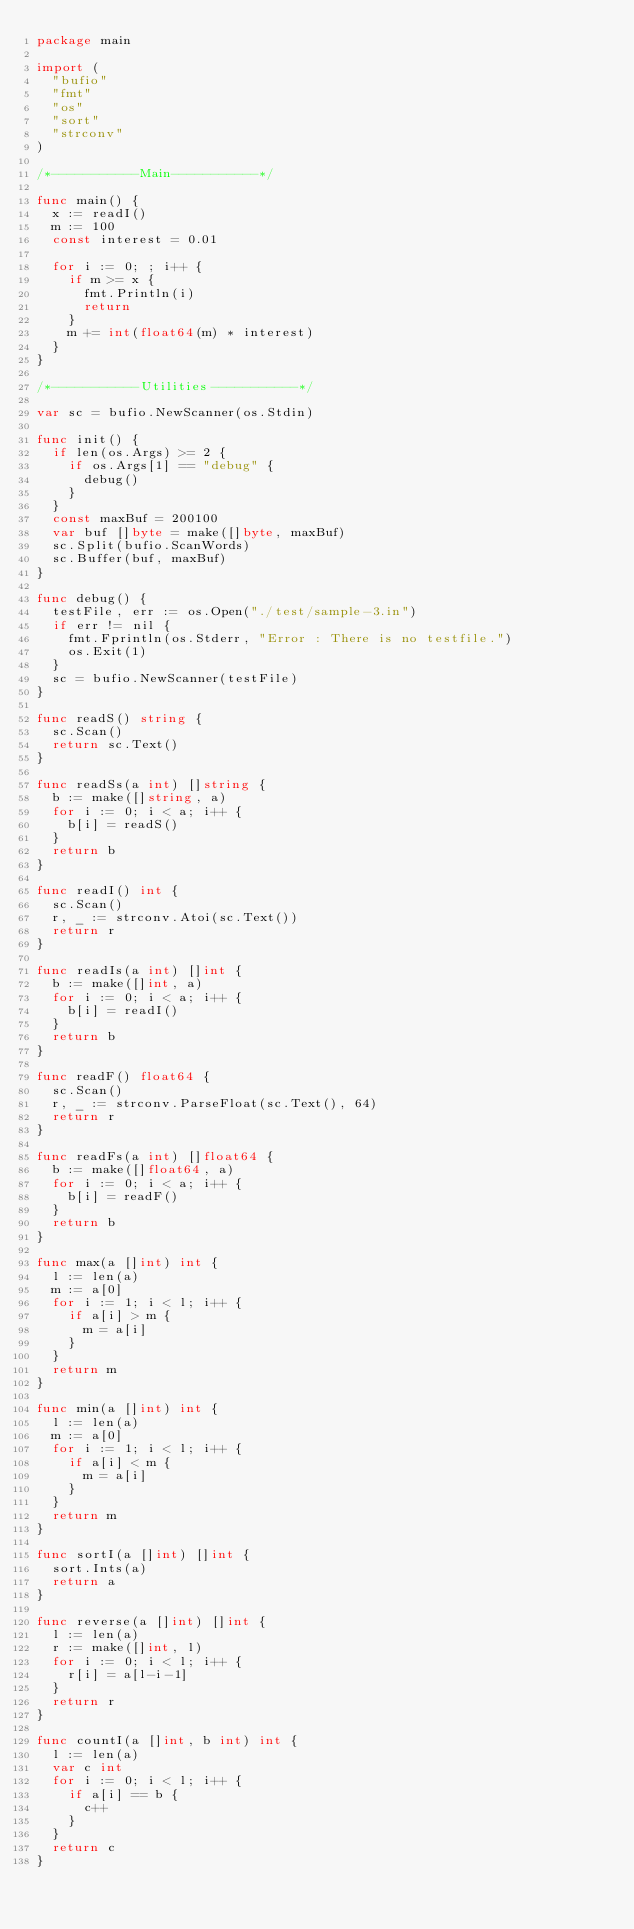Convert code to text. <code><loc_0><loc_0><loc_500><loc_500><_Go_>package main

import (
	"bufio"
	"fmt"
	"os"
	"sort"
	"strconv"
)

/*-----------Main-----------*/

func main() {
	x := readI()
	m := 100
	const interest = 0.01

	for i := 0; ; i++ {
		if m >= x {
			fmt.Println(i)
			return
		}
		m += int(float64(m) * interest)
	}
}

/*-----------Utilities-----------*/

var sc = bufio.NewScanner(os.Stdin)

func init() {
	if len(os.Args) >= 2 {
		if os.Args[1] == "debug" {
			debug()
		}
	}
	const maxBuf = 200100
	var buf []byte = make([]byte, maxBuf)
	sc.Split(bufio.ScanWords)
	sc.Buffer(buf, maxBuf)
}

func debug() {
	testFile, err := os.Open("./test/sample-3.in")
	if err != nil {
		fmt.Fprintln(os.Stderr, "Error : There is no testfile.")
		os.Exit(1)
	}
	sc = bufio.NewScanner(testFile)
}

func readS() string {
	sc.Scan()
	return sc.Text()
}

func readSs(a int) []string {
	b := make([]string, a)
	for i := 0; i < a; i++ {
		b[i] = readS()
	}
	return b
}

func readI() int {
	sc.Scan()
	r, _ := strconv.Atoi(sc.Text())
	return r
}

func readIs(a int) []int {
	b := make([]int, a)
	for i := 0; i < a; i++ {
		b[i] = readI()
	}
	return b
}

func readF() float64 {
	sc.Scan()
	r, _ := strconv.ParseFloat(sc.Text(), 64)
	return r
}

func readFs(a int) []float64 {
	b := make([]float64, a)
	for i := 0; i < a; i++ {
		b[i] = readF()
	}
	return b
}

func max(a []int) int {
	l := len(a)
	m := a[0]
	for i := 1; i < l; i++ {
		if a[i] > m {
			m = a[i]
		}
	}
	return m
}

func min(a []int) int {
	l := len(a)
	m := a[0]
	for i := 1; i < l; i++ {
		if a[i] < m {
			m = a[i]
		}
	}
	return m
}

func sortI(a []int) []int {
	sort.Ints(a)
	return a
}

func reverse(a []int) []int {
	l := len(a)
	r := make([]int, l)
	for i := 0; i < l; i++ {
		r[i] = a[l-i-1]
	}
	return r
}

func countI(a []int, b int) int {
	l := len(a)
	var c int
	for i := 0; i < l; i++ {
		if a[i] == b {
			c++
		}
	}
	return c
}
</code> 